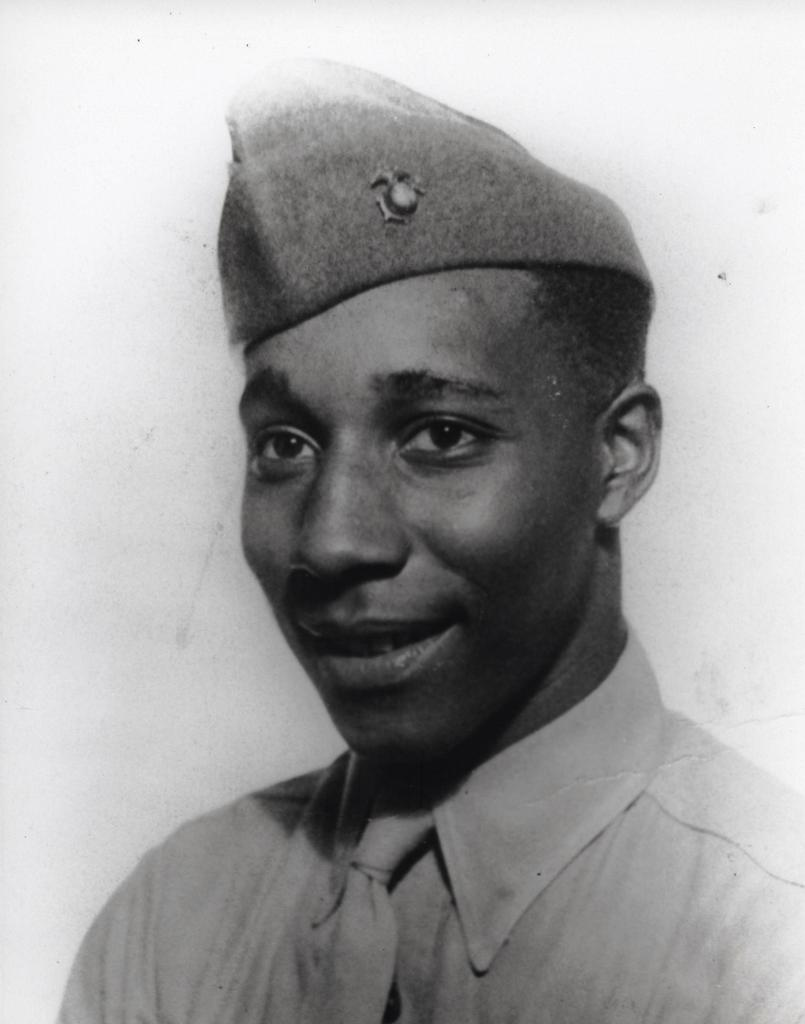What is the color scheme of the image? The image is black and white. Can you describe the person in the image? The person in the image is wearing a shirt, tie, and cap. What type of monkey can be seen wearing a sheet and mitten in the image? There is no monkey, sheet, or mitten present in the image; it features a person wearing a shirt, tie, and cap. 